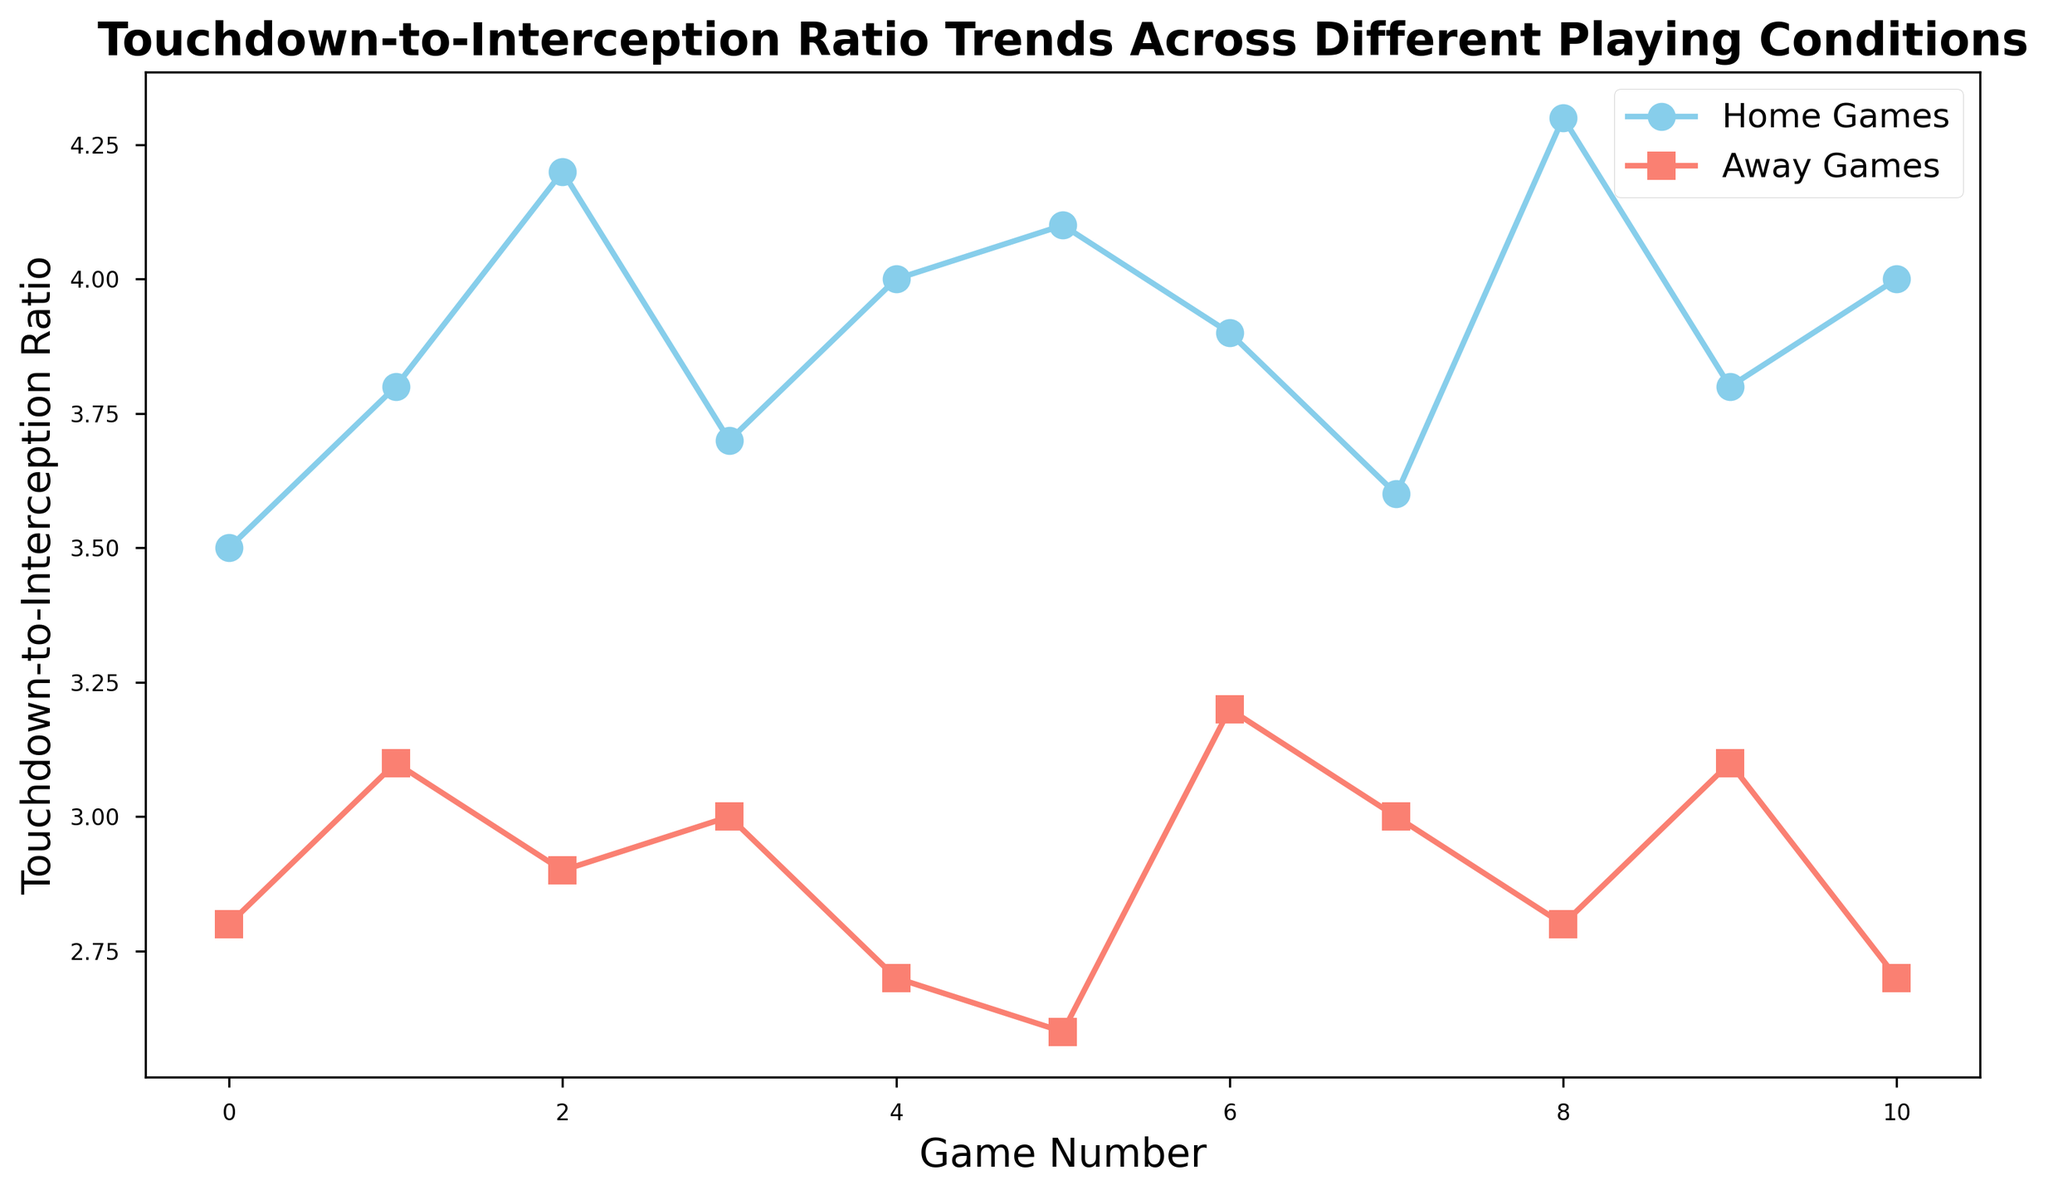What's the highest Touchdown-to-Interception Ratio for home games? Look at the trend line for home games and identify the maximum value on the y-axis for this series. The highest value is 4.3.
Answer: 4.3 Which playing condition shows a more stable trend? Compare the fluctuation in the ratios for home and away games. The home games have a more stable trend as the touchdowns-to-interceptions ratios vary less compared to the away games.
Answer: Home games What’s the average Touchdown-to-Interception Ratio for away games? Sum all the Touchdown-to-Interception Ratios for away games (2.8 + 3.1 + 2.9 + 3.0 + 2.7 + 2.6 + 3.2 + 3.0 + 2.8 + 3.1 + 2.7) and then divide by the number of data points (11). Calculation: (2.8 + 3.1 + 2.9 + 3.0 + 2.7 + 2.6 + 3.2 + 3.0 + 2.8 + 3.1 + 2.7) / 11 = 3.0
Answer: 3.0 On average, do home games have a higher Touchdown-to-Interception Ratio compared to away games? Calculate the average for both conditions: (3.5 + 3.8 + 4.2 + 3.7 + 4.0 + 4.1 + 3.9 + 3.6 + 4.3 + 3.8 + 4.0) / 11 = 3.91 for home games; and for away games, previously calculated as 3.0. Home average (3.91) is higher than away average (3.0).
Answer: Yes How many home games have a Touchdown-to-Interception Ratio greater than 4.0? Identify the points in the home games series where the ratio exceeds 4.0. Points are at values 4.2, 4.0, 4.1, 4.3, and 4.0. There are 5 such points.
Answer: 5 Is the first game ratio higher in home or away games? Check the first Touchdown-to-Interception Ratio for both home (3.5) and away (2.8) games. Home game's ratio (3.5) is higher.
Answer: Home games What's the difference between the highest ratio of home games and the lowest ratio of away games? Identify the highest ratio for home games (4.3) and the lowest ratio for away games (2.6). The difference is 4.3 - 2.6 = 1.7.
Answer: 1.7 Which game condition has a ratio of 2.6? Look for the point with 2.6 on the y-axis and identify the corresponding game condition color and marker. The 2.6 ratio is shown in away games.
Answer: Away games What's the total sum of the ratios for home games? Sum all the Touchdown-to-Interception Ratios for home games: 3.5 + 3.8 + 4.2 + 3.7 + 4.0 + 4.1 + 3.9 + 3.6 + 4.3 + 3.8 + 4.0. The sum is 43.9.
Answer: 43.9 